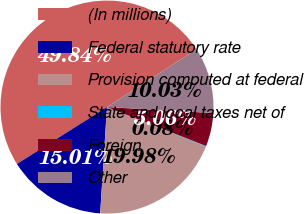<chart> <loc_0><loc_0><loc_500><loc_500><pie_chart><fcel>(In millions)<fcel>Federal statutory rate<fcel>Provision computed at federal<fcel>State and local taxes net of<fcel>Foreign<fcel>Other<nl><fcel>49.84%<fcel>15.01%<fcel>19.98%<fcel>0.08%<fcel>5.06%<fcel>10.03%<nl></chart> 